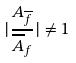<formula> <loc_0><loc_0><loc_500><loc_500>| \frac { A _ { \overline { f } } } { \overline { A } _ { f } } | \ne 1</formula> 